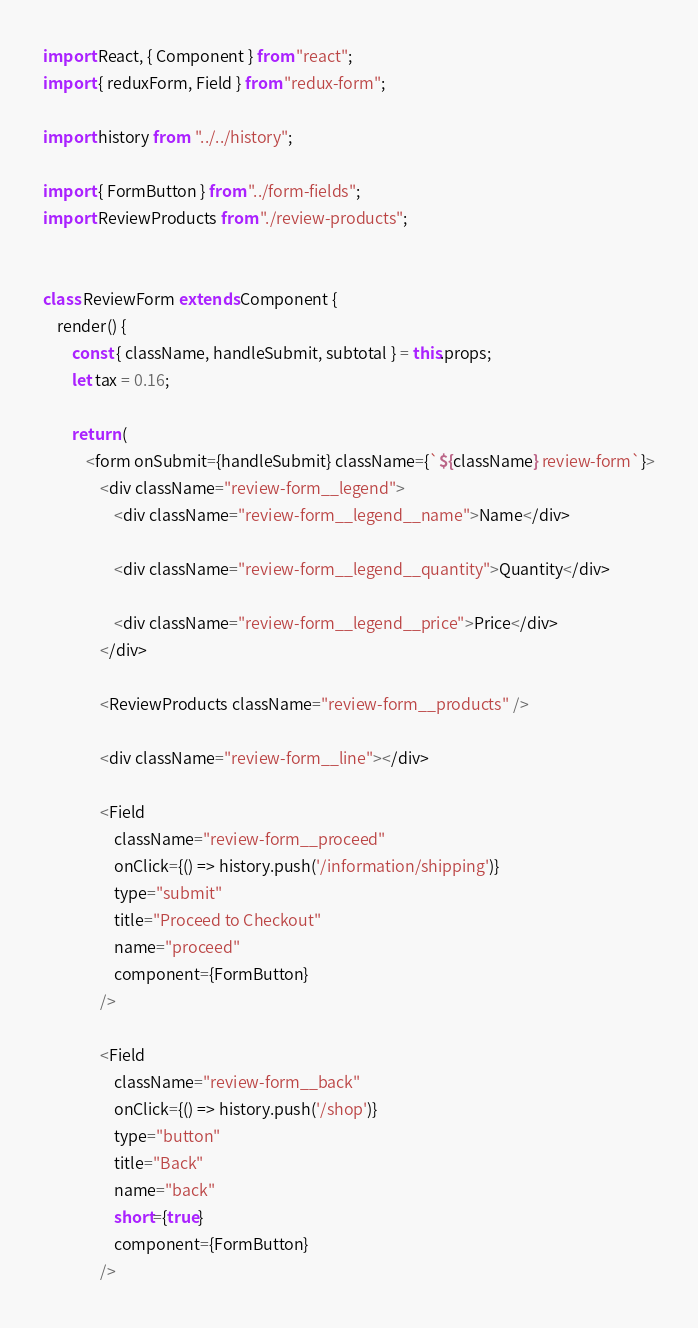Convert code to text. <code><loc_0><loc_0><loc_500><loc_500><_JavaScript_>import React, { Component } from "react";
import { reduxForm, Field } from "redux-form";

import history from  "../../history";

import { FormButton } from "../form-fields";
import ReviewProducts from "./review-products";


class ReviewForm extends Component {
    render() {
        const { className, handleSubmit, subtotal } = this.props;
        let tax = 0.16;
        
        return (
            <form onSubmit={handleSubmit} className={`${className} review-form`}>
                <div className="review-form__legend">
                    <div className="review-form__legend__name">Name</div>

                    <div className="review-form__legend__quantity">Quantity</div>

                    <div className="review-form__legend__price">Price</div>
                </div>
                
                <ReviewProducts className="review-form__products" />

                <div className="review-form__line"></div>

                <Field 
                    className="review-form__proceed" 
                    onClick={() => history.push('/information/shipping')}
                    type="submit" 
                    title="Proceed to Checkout"
                    name="proceed" 
                    component={FormButton} 
                />

                <Field 
                    className="review-form__back" 
                    onClick={() => history.push('/shop')}
                    type="button" 
                    title="Back" 
                    name="back" 
                    short={true}
                    component={FormButton} 
                />
</code> 